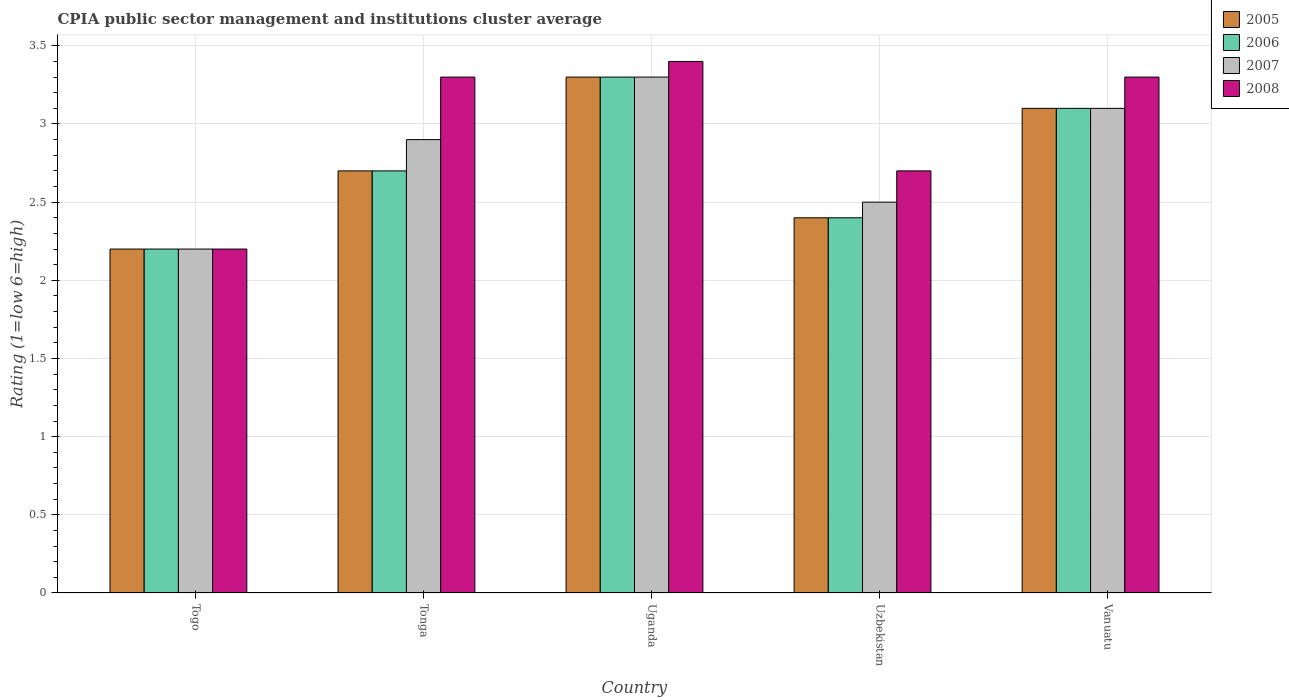How many different coloured bars are there?
Offer a terse response. 4. Are the number of bars per tick equal to the number of legend labels?
Offer a very short reply. Yes. How many bars are there on the 1st tick from the right?
Your answer should be compact. 4. What is the label of the 2nd group of bars from the left?
Keep it short and to the point. Tonga. In how many cases, is the number of bars for a given country not equal to the number of legend labels?
Make the answer very short. 0. What is the CPIA rating in 2007 in Uzbekistan?
Provide a short and direct response. 2.5. Across all countries, what is the minimum CPIA rating in 2007?
Give a very brief answer. 2.2. In which country was the CPIA rating in 2005 maximum?
Keep it short and to the point. Uganda. In which country was the CPIA rating in 2008 minimum?
Offer a very short reply. Togo. What is the total CPIA rating in 2008 in the graph?
Ensure brevity in your answer.  14.9. What is the difference between the CPIA rating in 2005 in Uzbekistan and that in Vanuatu?
Offer a terse response. -0.7. What is the difference between the CPIA rating in 2007 in Tonga and the CPIA rating in 2008 in Uzbekistan?
Give a very brief answer. 0.2. What is the average CPIA rating in 2005 per country?
Ensure brevity in your answer.  2.74. What is the difference between the CPIA rating of/in 2005 and CPIA rating of/in 2007 in Togo?
Your response must be concise. 0. What is the ratio of the CPIA rating in 2008 in Uganda to that in Uzbekistan?
Provide a short and direct response. 1.26. Is the difference between the CPIA rating in 2005 in Togo and Uzbekistan greater than the difference between the CPIA rating in 2007 in Togo and Uzbekistan?
Offer a terse response. Yes. What is the difference between the highest and the second highest CPIA rating in 2006?
Keep it short and to the point. 0.4. What is the difference between the highest and the lowest CPIA rating in 2006?
Your response must be concise. 1.1. In how many countries, is the CPIA rating in 2008 greater than the average CPIA rating in 2008 taken over all countries?
Make the answer very short. 3. Is the sum of the CPIA rating in 2008 in Uganda and Vanuatu greater than the maximum CPIA rating in 2006 across all countries?
Your answer should be compact. Yes. Is it the case that in every country, the sum of the CPIA rating in 2007 and CPIA rating in 2006 is greater than the sum of CPIA rating in 2008 and CPIA rating in 2005?
Your answer should be compact. No. What does the 3rd bar from the right in Vanuatu represents?
Ensure brevity in your answer.  2006. How many countries are there in the graph?
Offer a terse response. 5. What is the difference between two consecutive major ticks on the Y-axis?
Keep it short and to the point. 0.5. Are the values on the major ticks of Y-axis written in scientific E-notation?
Your answer should be very brief. No. Where does the legend appear in the graph?
Ensure brevity in your answer.  Top right. How many legend labels are there?
Offer a very short reply. 4. What is the title of the graph?
Your answer should be very brief. CPIA public sector management and institutions cluster average. Does "1983" appear as one of the legend labels in the graph?
Your answer should be compact. No. What is the label or title of the X-axis?
Keep it short and to the point. Country. What is the label or title of the Y-axis?
Your answer should be compact. Rating (1=low 6=high). What is the Rating (1=low 6=high) of 2006 in Togo?
Make the answer very short. 2.2. What is the Rating (1=low 6=high) of 2007 in Togo?
Ensure brevity in your answer.  2.2. What is the Rating (1=low 6=high) in 2005 in Tonga?
Your response must be concise. 2.7. What is the Rating (1=low 6=high) in 2006 in Tonga?
Make the answer very short. 2.7. What is the Rating (1=low 6=high) in 2006 in Uganda?
Your response must be concise. 3.3. What is the Rating (1=low 6=high) in 2007 in Uganda?
Your response must be concise. 3.3. What is the Rating (1=low 6=high) in 2006 in Uzbekistan?
Keep it short and to the point. 2.4. What is the Rating (1=low 6=high) of 2005 in Vanuatu?
Your answer should be compact. 3.1. What is the Rating (1=low 6=high) in 2006 in Vanuatu?
Provide a short and direct response. 3.1. What is the Rating (1=low 6=high) in 2008 in Vanuatu?
Make the answer very short. 3.3. Across all countries, what is the maximum Rating (1=low 6=high) in 2006?
Keep it short and to the point. 3.3. Across all countries, what is the maximum Rating (1=low 6=high) of 2007?
Provide a succinct answer. 3.3. Across all countries, what is the minimum Rating (1=low 6=high) in 2008?
Give a very brief answer. 2.2. What is the total Rating (1=low 6=high) of 2006 in the graph?
Provide a short and direct response. 13.7. What is the total Rating (1=low 6=high) of 2007 in the graph?
Give a very brief answer. 14. What is the total Rating (1=low 6=high) in 2008 in the graph?
Give a very brief answer. 14.9. What is the difference between the Rating (1=low 6=high) of 2006 in Togo and that in Tonga?
Provide a succinct answer. -0.5. What is the difference between the Rating (1=low 6=high) of 2005 in Togo and that in Uganda?
Ensure brevity in your answer.  -1.1. What is the difference between the Rating (1=low 6=high) in 2006 in Togo and that in Uganda?
Your answer should be compact. -1.1. What is the difference between the Rating (1=low 6=high) of 2006 in Togo and that in Uzbekistan?
Offer a very short reply. -0.2. What is the difference between the Rating (1=low 6=high) in 2008 in Togo and that in Uzbekistan?
Make the answer very short. -0.5. What is the difference between the Rating (1=low 6=high) in 2007 in Togo and that in Vanuatu?
Make the answer very short. -0.9. What is the difference between the Rating (1=low 6=high) in 2006 in Tonga and that in Uganda?
Offer a terse response. -0.6. What is the difference between the Rating (1=low 6=high) of 2007 in Tonga and that in Uganda?
Keep it short and to the point. -0.4. What is the difference between the Rating (1=low 6=high) of 2005 in Tonga and that in Uzbekistan?
Offer a very short reply. 0.3. What is the difference between the Rating (1=low 6=high) in 2006 in Tonga and that in Uzbekistan?
Your answer should be compact. 0.3. What is the difference between the Rating (1=low 6=high) in 2007 in Tonga and that in Vanuatu?
Provide a short and direct response. -0.2. What is the difference between the Rating (1=low 6=high) in 2007 in Uganda and that in Uzbekistan?
Ensure brevity in your answer.  0.8. What is the difference between the Rating (1=low 6=high) in 2008 in Uganda and that in Uzbekistan?
Your answer should be very brief. 0.7. What is the difference between the Rating (1=low 6=high) in 2005 in Uganda and that in Vanuatu?
Make the answer very short. 0.2. What is the difference between the Rating (1=low 6=high) of 2006 in Uganda and that in Vanuatu?
Offer a terse response. 0.2. What is the difference between the Rating (1=low 6=high) in 2005 in Uzbekistan and that in Vanuatu?
Your answer should be compact. -0.7. What is the difference between the Rating (1=low 6=high) of 2006 in Uzbekistan and that in Vanuatu?
Offer a terse response. -0.7. What is the difference between the Rating (1=low 6=high) of 2007 in Uzbekistan and that in Vanuatu?
Offer a very short reply. -0.6. What is the difference between the Rating (1=low 6=high) in 2005 in Togo and the Rating (1=low 6=high) in 2008 in Tonga?
Your response must be concise. -1.1. What is the difference between the Rating (1=low 6=high) of 2006 in Togo and the Rating (1=low 6=high) of 2007 in Tonga?
Keep it short and to the point. -0.7. What is the difference between the Rating (1=low 6=high) in 2006 in Togo and the Rating (1=low 6=high) in 2008 in Tonga?
Your answer should be compact. -1.1. What is the difference between the Rating (1=low 6=high) of 2005 in Togo and the Rating (1=low 6=high) of 2006 in Uzbekistan?
Give a very brief answer. -0.2. What is the difference between the Rating (1=low 6=high) of 2006 in Togo and the Rating (1=low 6=high) of 2008 in Uzbekistan?
Give a very brief answer. -0.5. What is the difference between the Rating (1=low 6=high) of 2007 in Togo and the Rating (1=low 6=high) of 2008 in Uzbekistan?
Your answer should be compact. -0.5. What is the difference between the Rating (1=low 6=high) in 2005 in Togo and the Rating (1=low 6=high) in 2008 in Vanuatu?
Make the answer very short. -1.1. What is the difference between the Rating (1=low 6=high) of 2006 in Togo and the Rating (1=low 6=high) of 2008 in Vanuatu?
Your response must be concise. -1.1. What is the difference between the Rating (1=low 6=high) of 2007 in Togo and the Rating (1=low 6=high) of 2008 in Vanuatu?
Your answer should be compact. -1.1. What is the difference between the Rating (1=low 6=high) of 2005 in Tonga and the Rating (1=low 6=high) of 2006 in Uganda?
Keep it short and to the point. -0.6. What is the difference between the Rating (1=low 6=high) of 2006 in Tonga and the Rating (1=low 6=high) of 2007 in Uganda?
Ensure brevity in your answer.  -0.6. What is the difference between the Rating (1=low 6=high) in 2005 in Tonga and the Rating (1=low 6=high) in 2008 in Uzbekistan?
Provide a succinct answer. 0. What is the difference between the Rating (1=low 6=high) of 2006 in Tonga and the Rating (1=low 6=high) of 2008 in Uzbekistan?
Give a very brief answer. 0. What is the difference between the Rating (1=low 6=high) of 2005 in Tonga and the Rating (1=low 6=high) of 2006 in Vanuatu?
Offer a very short reply. -0.4. What is the difference between the Rating (1=low 6=high) of 2005 in Tonga and the Rating (1=low 6=high) of 2008 in Vanuatu?
Provide a short and direct response. -0.6. What is the difference between the Rating (1=low 6=high) of 2006 in Tonga and the Rating (1=low 6=high) of 2007 in Vanuatu?
Ensure brevity in your answer.  -0.4. What is the difference between the Rating (1=low 6=high) in 2007 in Tonga and the Rating (1=low 6=high) in 2008 in Vanuatu?
Your answer should be compact. -0.4. What is the difference between the Rating (1=low 6=high) in 2005 in Uganda and the Rating (1=low 6=high) in 2007 in Uzbekistan?
Keep it short and to the point. 0.8. What is the difference between the Rating (1=low 6=high) in 2005 in Uganda and the Rating (1=low 6=high) in 2008 in Uzbekistan?
Make the answer very short. 0.6. What is the difference between the Rating (1=low 6=high) in 2006 in Uganda and the Rating (1=low 6=high) in 2007 in Uzbekistan?
Provide a short and direct response. 0.8. What is the difference between the Rating (1=low 6=high) of 2005 in Uganda and the Rating (1=low 6=high) of 2007 in Vanuatu?
Keep it short and to the point. 0.2. What is the difference between the Rating (1=low 6=high) in 2005 in Uganda and the Rating (1=low 6=high) in 2008 in Vanuatu?
Make the answer very short. 0. What is the difference between the Rating (1=low 6=high) of 2005 in Uzbekistan and the Rating (1=low 6=high) of 2007 in Vanuatu?
Make the answer very short. -0.7. What is the difference between the Rating (1=low 6=high) of 2005 in Uzbekistan and the Rating (1=low 6=high) of 2008 in Vanuatu?
Your response must be concise. -0.9. What is the difference between the Rating (1=low 6=high) in 2006 in Uzbekistan and the Rating (1=low 6=high) in 2007 in Vanuatu?
Keep it short and to the point. -0.7. What is the difference between the Rating (1=low 6=high) in 2006 in Uzbekistan and the Rating (1=low 6=high) in 2008 in Vanuatu?
Make the answer very short. -0.9. What is the average Rating (1=low 6=high) of 2005 per country?
Provide a short and direct response. 2.74. What is the average Rating (1=low 6=high) of 2006 per country?
Offer a very short reply. 2.74. What is the average Rating (1=low 6=high) in 2007 per country?
Provide a short and direct response. 2.8. What is the average Rating (1=low 6=high) of 2008 per country?
Your answer should be compact. 2.98. What is the difference between the Rating (1=low 6=high) of 2005 and Rating (1=low 6=high) of 2008 in Togo?
Provide a succinct answer. 0. What is the difference between the Rating (1=low 6=high) of 2006 and Rating (1=low 6=high) of 2008 in Togo?
Your answer should be compact. 0. What is the difference between the Rating (1=low 6=high) of 2005 and Rating (1=low 6=high) of 2007 in Tonga?
Your answer should be very brief. -0.2. What is the difference between the Rating (1=low 6=high) in 2005 and Rating (1=low 6=high) in 2008 in Tonga?
Make the answer very short. -0.6. What is the difference between the Rating (1=low 6=high) of 2006 and Rating (1=low 6=high) of 2007 in Tonga?
Offer a terse response. -0.2. What is the difference between the Rating (1=low 6=high) of 2007 and Rating (1=low 6=high) of 2008 in Tonga?
Ensure brevity in your answer.  -0.4. What is the difference between the Rating (1=low 6=high) of 2006 and Rating (1=low 6=high) of 2008 in Uganda?
Offer a terse response. -0.1. What is the difference between the Rating (1=low 6=high) of 2007 and Rating (1=low 6=high) of 2008 in Uganda?
Give a very brief answer. -0.1. What is the difference between the Rating (1=low 6=high) of 2005 and Rating (1=low 6=high) of 2007 in Uzbekistan?
Make the answer very short. -0.1. What is the difference between the Rating (1=low 6=high) in 2005 and Rating (1=low 6=high) in 2008 in Uzbekistan?
Your answer should be compact. -0.3. What is the difference between the Rating (1=low 6=high) of 2006 and Rating (1=low 6=high) of 2007 in Uzbekistan?
Provide a short and direct response. -0.1. What is the difference between the Rating (1=low 6=high) in 2006 and Rating (1=low 6=high) in 2008 in Uzbekistan?
Ensure brevity in your answer.  -0.3. What is the difference between the Rating (1=low 6=high) in 2005 and Rating (1=low 6=high) in 2007 in Vanuatu?
Provide a succinct answer. 0. What is the difference between the Rating (1=low 6=high) in 2006 and Rating (1=low 6=high) in 2008 in Vanuatu?
Provide a short and direct response. -0.2. What is the ratio of the Rating (1=low 6=high) of 2005 in Togo to that in Tonga?
Provide a succinct answer. 0.81. What is the ratio of the Rating (1=low 6=high) in 2006 in Togo to that in Tonga?
Ensure brevity in your answer.  0.81. What is the ratio of the Rating (1=low 6=high) in 2007 in Togo to that in Tonga?
Keep it short and to the point. 0.76. What is the ratio of the Rating (1=low 6=high) in 2007 in Togo to that in Uganda?
Provide a succinct answer. 0.67. What is the ratio of the Rating (1=low 6=high) of 2008 in Togo to that in Uganda?
Offer a terse response. 0.65. What is the ratio of the Rating (1=low 6=high) of 2007 in Togo to that in Uzbekistan?
Provide a succinct answer. 0.88. What is the ratio of the Rating (1=low 6=high) in 2008 in Togo to that in Uzbekistan?
Provide a succinct answer. 0.81. What is the ratio of the Rating (1=low 6=high) of 2005 in Togo to that in Vanuatu?
Your response must be concise. 0.71. What is the ratio of the Rating (1=low 6=high) in 2006 in Togo to that in Vanuatu?
Provide a short and direct response. 0.71. What is the ratio of the Rating (1=low 6=high) in 2007 in Togo to that in Vanuatu?
Your response must be concise. 0.71. What is the ratio of the Rating (1=low 6=high) in 2008 in Togo to that in Vanuatu?
Your answer should be very brief. 0.67. What is the ratio of the Rating (1=low 6=high) of 2005 in Tonga to that in Uganda?
Give a very brief answer. 0.82. What is the ratio of the Rating (1=low 6=high) in 2006 in Tonga to that in Uganda?
Ensure brevity in your answer.  0.82. What is the ratio of the Rating (1=low 6=high) in 2007 in Tonga to that in Uganda?
Your answer should be compact. 0.88. What is the ratio of the Rating (1=low 6=high) in 2008 in Tonga to that in Uganda?
Keep it short and to the point. 0.97. What is the ratio of the Rating (1=low 6=high) of 2005 in Tonga to that in Uzbekistan?
Provide a succinct answer. 1.12. What is the ratio of the Rating (1=low 6=high) of 2006 in Tonga to that in Uzbekistan?
Ensure brevity in your answer.  1.12. What is the ratio of the Rating (1=low 6=high) in 2007 in Tonga to that in Uzbekistan?
Provide a short and direct response. 1.16. What is the ratio of the Rating (1=low 6=high) in 2008 in Tonga to that in Uzbekistan?
Your response must be concise. 1.22. What is the ratio of the Rating (1=low 6=high) in 2005 in Tonga to that in Vanuatu?
Offer a very short reply. 0.87. What is the ratio of the Rating (1=low 6=high) of 2006 in Tonga to that in Vanuatu?
Make the answer very short. 0.87. What is the ratio of the Rating (1=low 6=high) in 2007 in Tonga to that in Vanuatu?
Offer a terse response. 0.94. What is the ratio of the Rating (1=low 6=high) of 2005 in Uganda to that in Uzbekistan?
Give a very brief answer. 1.38. What is the ratio of the Rating (1=low 6=high) in 2006 in Uganda to that in Uzbekistan?
Ensure brevity in your answer.  1.38. What is the ratio of the Rating (1=low 6=high) of 2007 in Uganda to that in Uzbekistan?
Offer a very short reply. 1.32. What is the ratio of the Rating (1=low 6=high) in 2008 in Uganda to that in Uzbekistan?
Offer a very short reply. 1.26. What is the ratio of the Rating (1=low 6=high) in 2005 in Uganda to that in Vanuatu?
Your answer should be very brief. 1.06. What is the ratio of the Rating (1=low 6=high) in 2006 in Uganda to that in Vanuatu?
Provide a succinct answer. 1.06. What is the ratio of the Rating (1=low 6=high) in 2007 in Uganda to that in Vanuatu?
Make the answer very short. 1.06. What is the ratio of the Rating (1=low 6=high) of 2008 in Uganda to that in Vanuatu?
Your answer should be compact. 1.03. What is the ratio of the Rating (1=low 6=high) in 2005 in Uzbekistan to that in Vanuatu?
Offer a terse response. 0.77. What is the ratio of the Rating (1=low 6=high) in 2006 in Uzbekistan to that in Vanuatu?
Provide a short and direct response. 0.77. What is the ratio of the Rating (1=low 6=high) of 2007 in Uzbekistan to that in Vanuatu?
Ensure brevity in your answer.  0.81. What is the ratio of the Rating (1=low 6=high) in 2008 in Uzbekistan to that in Vanuatu?
Provide a succinct answer. 0.82. What is the difference between the highest and the lowest Rating (1=low 6=high) in 2005?
Make the answer very short. 1.1. 